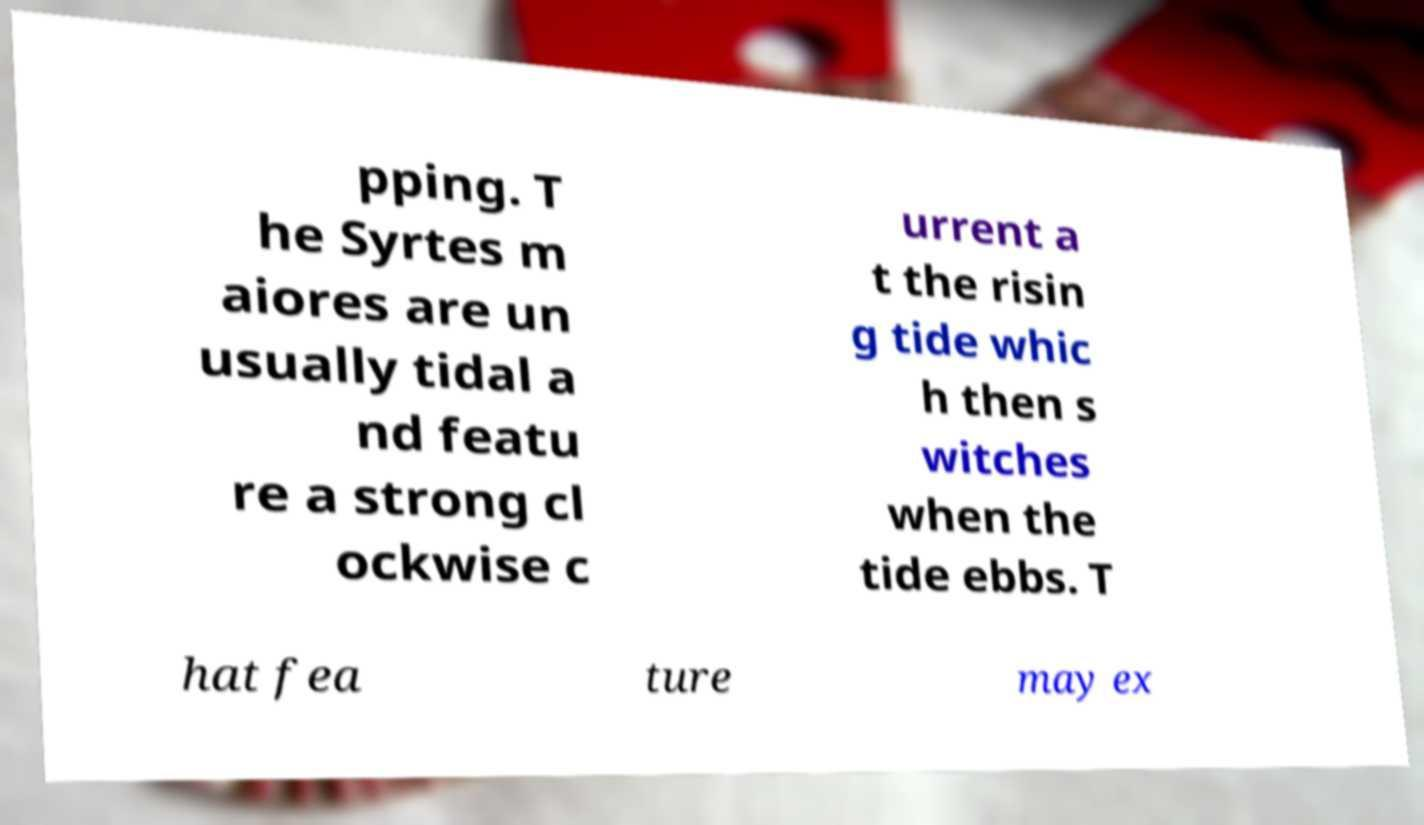There's text embedded in this image that I need extracted. Can you transcribe it verbatim? pping. T he Syrtes m aiores are un usually tidal a nd featu re a strong cl ockwise c urrent a t the risin g tide whic h then s witches when the tide ebbs. T hat fea ture may ex 